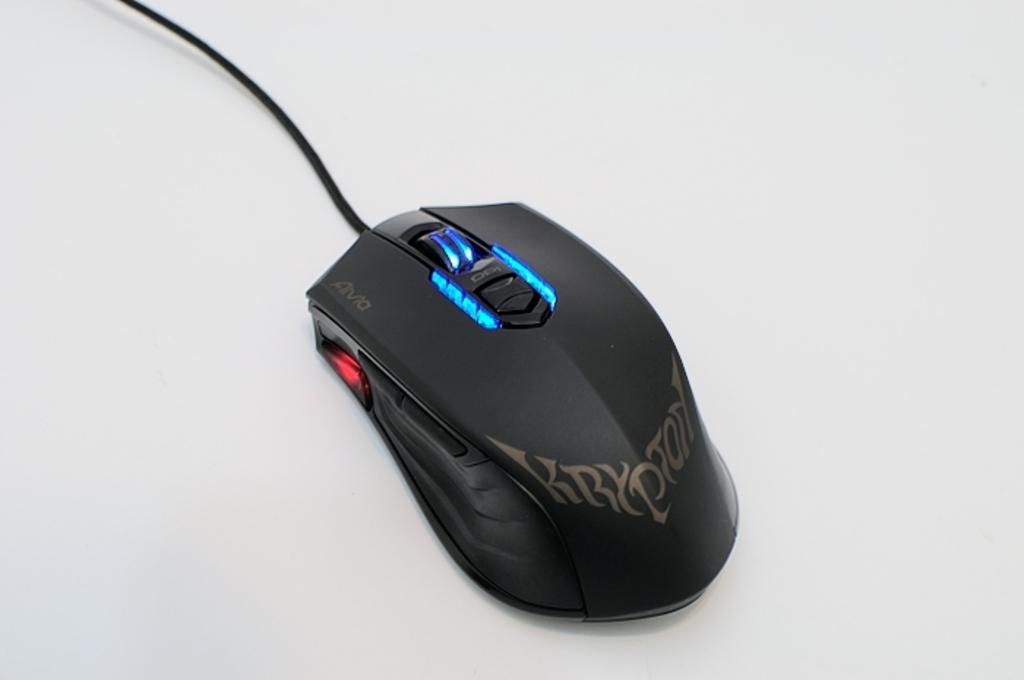What is on the left button?
Make the answer very short. Avia. 